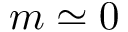Convert formula to latex. <formula><loc_0><loc_0><loc_500><loc_500>m \simeq 0</formula> 